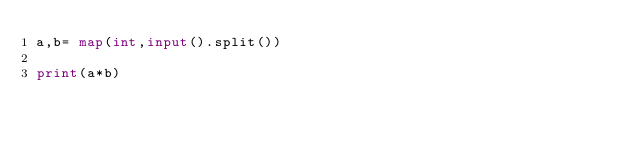<code> <loc_0><loc_0><loc_500><loc_500><_Python_>a,b= map(int,input().split())

print(a*b)
</code> 